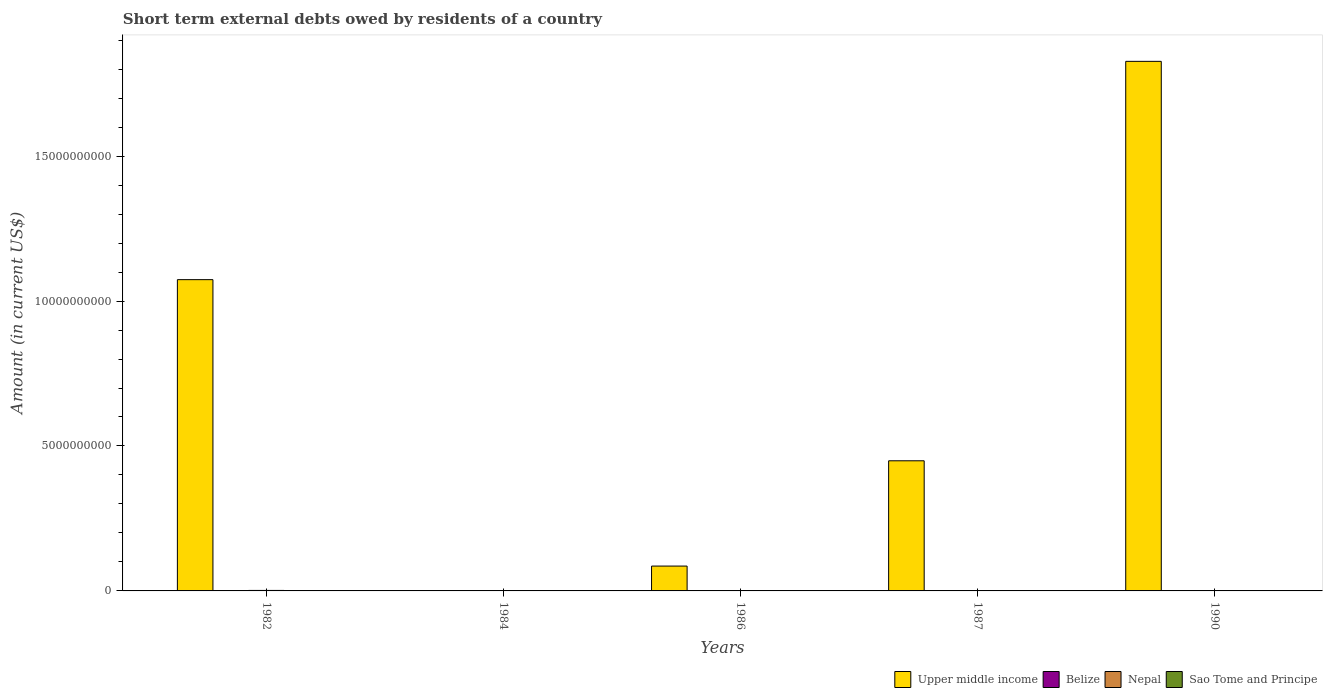How many bars are there on the 1st tick from the left?
Offer a very short reply. 3. What is the amount of short-term external debts owed by residents in Belize in 1990?
Provide a succinct answer. 7.56e+05. Across all years, what is the maximum amount of short-term external debts owed by residents in Nepal?
Your answer should be very brief. 1.70e+07. Across all years, what is the minimum amount of short-term external debts owed by residents in Belize?
Ensure brevity in your answer.  0. What is the total amount of short-term external debts owed by residents in Nepal in the graph?
Your answer should be compact. 1.94e+07. What is the difference between the amount of short-term external debts owed by residents in Belize in 1987 and that in 1990?
Ensure brevity in your answer.  2.24e+06. What is the average amount of short-term external debts owed by residents in Belize per year?
Give a very brief answer. 1.35e+06. In the year 1982, what is the difference between the amount of short-term external debts owed by residents in Nepal and amount of short-term external debts owed by residents in Upper middle income?
Give a very brief answer. -1.07e+1. In how many years, is the amount of short-term external debts owed by residents in Upper middle income greater than 15000000000 US$?
Offer a very short reply. 1. What is the ratio of the amount of short-term external debts owed by residents in Upper middle income in 1986 to that in 1987?
Provide a short and direct response. 0.19. Is the amount of short-term external debts owed by residents in Upper middle income in 1986 less than that in 1990?
Provide a succinct answer. Yes. What is the difference between the highest and the second highest amount of short-term external debts owed by residents in Upper middle income?
Your response must be concise. 7.53e+09. What is the difference between the highest and the lowest amount of short-term external debts owed by residents in Belize?
Offer a terse response. 3.00e+06. Is it the case that in every year, the sum of the amount of short-term external debts owed by residents in Nepal and amount of short-term external debts owed by residents in Sao Tome and Principe is greater than the sum of amount of short-term external debts owed by residents in Belize and amount of short-term external debts owed by residents in Upper middle income?
Give a very brief answer. No. How many bars are there?
Offer a terse response. 11. How many years are there in the graph?
Your response must be concise. 5. Are the values on the major ticks of Y-axis written in scientific E-notation?
Make the answer very short. No. Does the graph contain any zero values?
Make the answer very short. Yes. Does the graph contain grids?
Offer a terse response. No. How many legend labels are there?
Keep it short and to the point. 4. What is the title of the graph?
Ensure brevity in your answer.  Short term external debts owed by residents of a country. Does "Sweden" appear as one of the legend labels in the graph?
Offer a terse response. No. What is the Amount (in current US$) in Upper middle income in 1982?
Your answer should be compact. 1.07e+1. What is the Amount (in current US$) of Nepal in 1982?
Ensure brevity in your answer.  1.70e+07. What is the Amount (in current US$) in Sao Tome and Principe in 1982?
Provide a succinct answer. 0. What is the Amount (in current US$) in Upper middle income in 1984?
Offer a very short reply. 0. What is the Amount (in current US$) of Belize in 1984?
Offer a very short reply. 0. What is the Amount (in current US$) in Sao Tome and Principe in 1984?
Provide a short and direct response. 0. What is the Amount (in current US$) in Upper middle income in 1986?
Give a very brief answer. 8.57e+08. What is the Amount (in current US$) of Belize in 1986?
Your answer should be compact. 0. What is the Amount (in current US$) of Upper middle income in 1987?
Your response must be concise. 4.49e+09. What is the Amount (in current US$) in Nepal in 1987?
Ensure brevity in your answer.  0. What is the Amount (in current US$) in Sao Tome and Principe in 1987?
Ensure brevity in your answer.  2.51e+06. What is the Amount (in current US$) in Upper middle income in 1990?
Your response must be concise. 1.83e+1. What is the Amount (in current US$) of Belize in 1990?
Your response must be concise. 7.56e+05. What is the Amount (in current US$) in Nepal in 1990?
Ensure brevity in your answer.  2.40e+06. Across all years, what is the maximum Amount (in current US$) of Upper middle income?
Ensure brevity in your answer.  1.83e+1. Across all years, what is the maximum Amount (in current US$) of Belize?
Your response must be concise. 3.00e+06. Across all years, what is the maximum Amount (in current US$) of Nepal?
Your response must be concise. 1.70e+07. Across all years, what is the maximum Amount (in current US$) of Sao Tome and Principe?
Offer a terse response. 2.51e+06. Across all years, what is the minimum Amount (in current US$) in Upper middle income?
Provide a short and direct response. 0. What is the total Amount (in current US$) of Upper middle income in the graph?
Offer a very short reply. 3.44e+1. What is the total Amount (in current US$) of Belize in the graph?
Your response must be concise. 6.76e+06. What is the total Amount (in current US$) of Nepal in the graph?
Your answer should be very brief. 1.94e+07. What is the total Amount (in current US$) of Sao Tome and Principe in the graph?
Keep it short and to the point. 3.51e+06. What is the difference between the Amount (in current US$) in Upper middle income in 1982 and that in 1986?
Ensure brevity in your answer.  9.88e+09. What is the difference between the Amount (in current US$) of Upper middle income in 1982 and that in 1987?
Offer a terse response. 6.25e+09. What is the difference between the Amount (in current US$) in Upper middle income in 1982 and that in 1990?
Your answer should be very brief. -7.53e+09. What is the difference between the Amount (in current US$) of Belize in 1982 and that in 1990?
Offer a terse response. 2.24e+06. What is the difference between the Amount (in current US$) in Nepal in 1982 and that in 1990?
Ensure brevity in your answer.  1.46e+07. What is the difference between the Amount (in current US$) in Upper middle income in 1986 and that in 1987?
Make the answer very short. -3.63e+09. What is the difference between the Amount (in current US$) of Sao Tome and Principe in 1986 and that in 1987?
Your response must be concise. -1.51e+06. What is the difference between the Amount (in current US$) of Upper middle income in 1986 and that in 1990?
Your response must be concise. -1.74e+1. What is the difference between the Amount (in current US$) in Upper middle income in 1987 and that in 1990?
Make the answer very short. -1.38e+1. What is the difference between the Amount (in current US$) in Belize in 1987 and that in 1990?
Ensure brevity in your answer.  2.24e+06. What is the difference between the Amount (in current US$) of Upper middle income in 1982 and the Amount (in current US$) of Sao Tome and Principe in 1986?
Your answer should be compact. 1.07e+1. What is the difference between the Amount (in current US$) of Belize in 1982 and the Amount (in current US$) of Sao Tome and Principe in 1986?
Your answer should be compact. 2.00e+06. What is the difference between the Amount (in current US$) in Nepal in 1982 and the Amount (in current US$) in Sao Tome and Principe in 1986?
Offer a very short reply. 1.60e+07. What is the difference between the Amount (in current US$) of Upper middle income in 1982 and the Amount (in current US$) of Belize in 1987?
Make the answer very short. 1.07e+1. What is the difference between the Amount (in current US$) in Upper middle income in 1982 and the Amount (in current US$) in Sao Tome and Principe in 1987?
Your answer should be very brief. 1.07e+1. What is the difference between the Amount (in current US$) of Nepal in 1982 and the Amount (in current US$) of Sao Tome and Principe in 1987?
Offer a terse response. 1.45e+07. What is the difference between the Amount (in current US$) of Upper middle income in 1982 and the Amount (in current US$) of Belize in 1990?
Give a very brief answer. 1.07e+1. What is the difference between the Amount (in current US$) of Upper middle income in 1982 and the Amount (in current US$) of Nepal in 1990?
Your response must be concise. 1.07e+1. What is the difference between the Amount (in current US$) of Belize in 1982 and the Amount (in current US$) of Nepal in 1990?
Your response must be concise. 6.00e+05. What is the difference between the Amount (in current US$) of Upper middle income in 1986 and the Amount (in current US$) of Belize in 1987?
Ensure brevity in your answer.  8.54e+08. What is the difference between the Amount (in current US$) in Upper middle income in 1986 and the Amount (in current US$) in Sao Tome and Principe in 1987?
Offer a very short reply. 8.55e+08. What is the difference between the Amount (in current US$) of Upper middle income in 1986 and the Amount (in current US$) of Belize in 1990?
Give a very brief answer. 8.57e+08. What is the difference between the Amount (in current US$) in Upper middle income in 1986 and the Amount (in current US$) in Nepal in 1990?
Your answer should be very brief. 8.55e+08. What is the difference between the Amount (in current US$) in Upper middle income in 1987 and the Amount (in current US$) in Belize in 1990?
Give a very brief answer. 4.49e+09. What is the difference between the Amount (in current US$) of Upper middle income in 1987 and the Amount (in current US$) of Nepal in 1990?
Keep it short and to the point. 4.49e+09. What is the average Amount (in current US$) of Upper middle income per year?
Provide a succinct answer. 6.87e+09. What is the average Amount (in current US$) in Belize per year?
Provide a short and direct response. 1.35e+06. What is the average Amount (in current US$) of Nepal per year?
Make the answer very short. 3.88e+06. What is the average Amount (in current US$) in Sao Tome and Principe per year?
Provide a short and direct response. 7.02e+05. In the year 1982, what is the difference between the Amount (in current US$) of Upper middle income and Amount (in current US$) of Belize?
Make the answer very short. 1.07e+1. In the year 1982, what is the difference between the Amount (in current US$) of Upper middle income and Amount (in current US$) of Nepal?
Give a very brief answer. 1.07e+1. In the year 1982, what is the difference between the Amount (in current US$) in Belize and Amount (in current US$) in Nepal?
Your answer should be very brief. -1.40e+07. In the year 1986, what is the difference between the Amount (in current US$) in Upper middle income and Amount (in current US$) in Sao Tome and Principe?
Give a very brief answer. 8.56e+08. In the year 1987, what is the difference between the Amount (in current US$) of Upper middle income and Amount (in current US$) of Belize?
Your answer should be compact. 4.49e+09. In the year 1987, what is the difference between the Amount (in current US$) in Upper middle income and Amount (in current US$) in Sao Tome and Principe?
Offer a terse response. 4.49e+09. In the year 1987, what is the difference between the Amount (in current US$) of Belize and Amount (in current US$) of Sao Tome and Principe?
Your answer should be very brief. 4.90e+05. In the year 1990, what is the difference between the Amount (in current US$) in Upper middle income and Amount (in current US$) in Belize?
Ensure brevity in your answer.  1.83e+1. In the year 1990, what is the difference between the Amount (in current US$) of Upper middle income and Amount (in current US$) of Nepal?
Your answer should be very brief. 1.83e+1. In the year 1990, what is the difference between the Amount (in current US$) in Belize and Amount (in current US$) in Nepal?
Your response must be concise. -1.64e+06. What is the ratio of the Amount (in current US$) in Upper middle income in 1982 to that in 1986?
Provide a short and direct response. 12.52. What is the ratio of the Amount (in current US$) in Upper middle income in 1982 to that in 1987?
Your answer should be compact. 2.39. What is the ratio of the Amount (in current US$) of Upper middle income in 1982 to that in 1990?
Make the answer very short. 0.59. What is the ratio of the Amount (in current US$) of Belize in 1982 to that in 1990?
Your response must be concise. 3.97. What is the ratio of the Amount (in current US$) in Nepal in 1982 to that in 1990?
Your answer should be compact. 7.08. What is the ratio of the Amount (in current US$) in Upper middle income in 1986 to that in 1987?
Keep it short and to the point. 0.19. What is the ratio of the Amount (in current US$) in Sao Tome and Principe in 1986 to that in 1987?
Provide a succinct answer. 0.4. What is the ratio of the Amount (in current US$) of Upper middle income in 1986 to that in 1990?
Provide a short and direct response. 0.05. What is the ratio of the Amount (in current US$) of Upper middle income in 1987 to that in 1990?
Offer a terse response. 0.25. What is the ratio of the Amount (in current US$) of Belize in 1987 to that in 1990?
Offer a terse response. 3.97. What is the difference between the highest and the second highest Amount (in current US$) in Upper middle income?
Your answer should be compact. 7.53e+09. What is the difference between the highest and the second highest Amount (in current US$) of Belize?
Your answer should be very brief. 0. What is the difference between the highest and the lowest Amount (in current US$) in Upper middle income?
Offer a terse response. 1.83e+1. What is the difference between the highest and the lowest Amount (in current US$) in Belize?
Ensure brevity in your answer.  3.00e+06. What is the difference between the highest and the lowest Amount (in current US$) of Nepal?
Provide a short and direct response. 1.70e+07. What is the difference between the highest and the lowest Amount (in current US$) in Sao Tome and Principe?
Provide a short and direct response. 2.51e+06. 